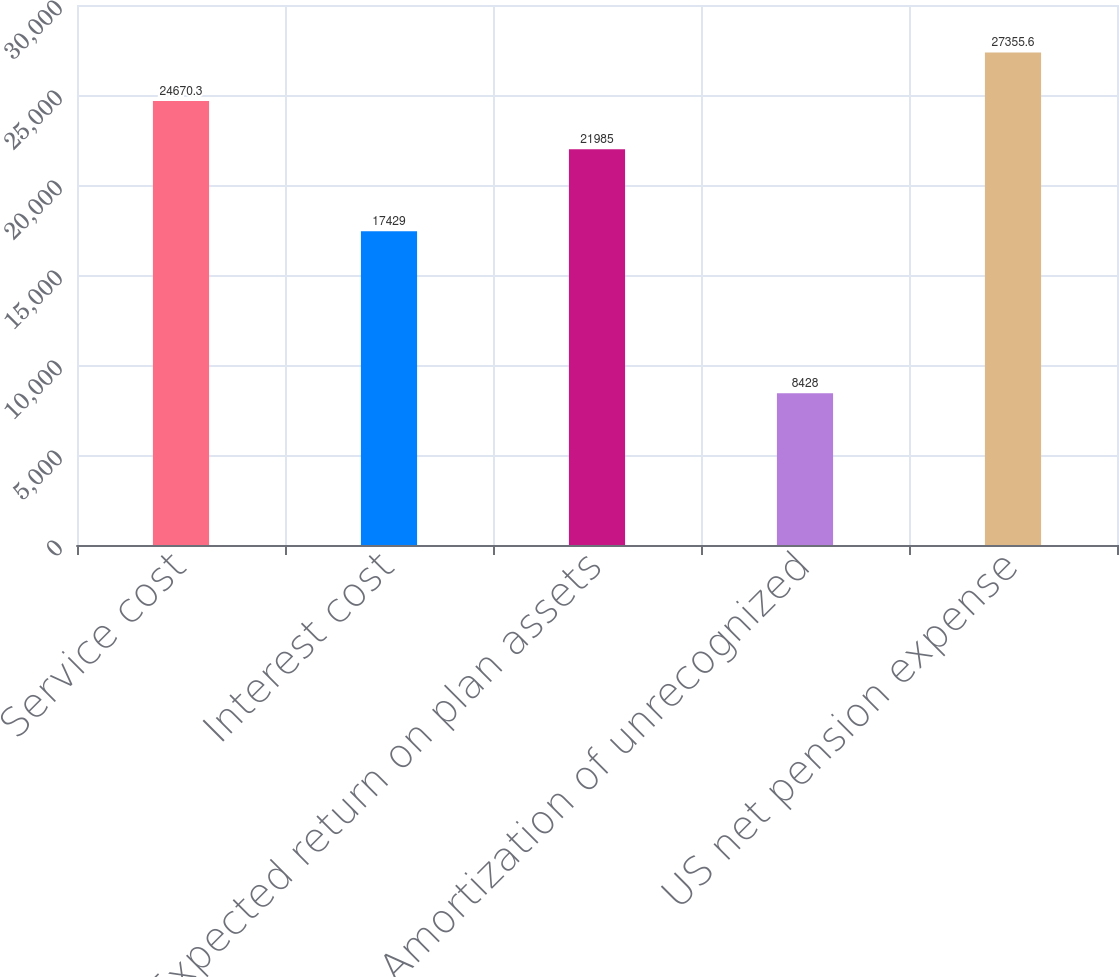<chart> <loc_0><loc_0><loc_500><loc_500><bar_chart><fcel>Service cost<fcel>Interest cost<fcel>Expected return on plan assets<fcel>Amortization of unrecognized<fcel>US net pension expense<nl><fcel>24670.3<fcel>17429<fcel>21985<fcel>8428<fcel>27355.6<nl></chart> 